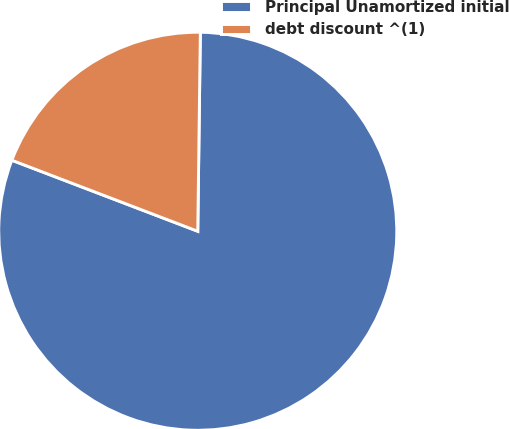Convert chart to OTSL. <chart><loc_0><loc_0><loc_500><loc_500><pie_chart><fcel>Principal Unamortized initial<fcel>debt discount ^(1)<nl><fcel>80.6%<fcel>19.4%<nl></chart> 